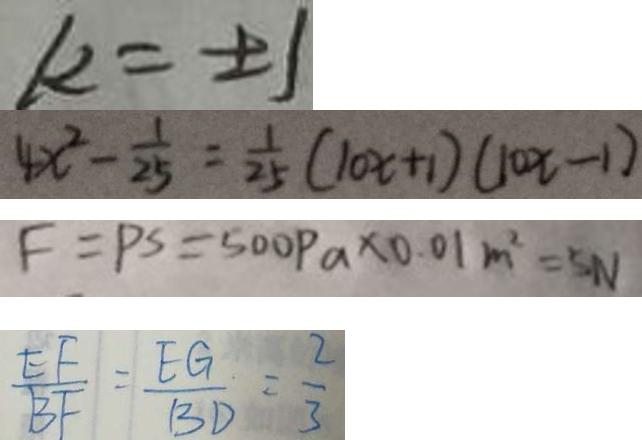Convert formula to latex. <formula><loc_0><loc_0><loc_500><loc_500>k = \pm 1 
 4 x ^ { 2 } - \frac { 1 } { 2 5 } = \frac { 1 } { 2 5 } ( 1 0 x + 1 ) ( 1 0 x - 1 ) 
 F = P s = 5 0 0 P a \times 0 . 0 1 m ^ { 2 } = 5 N 
 \frac { E F } { B F } = \frac { E G } { B D } = \frac { 2 } { 3 }</formula> 